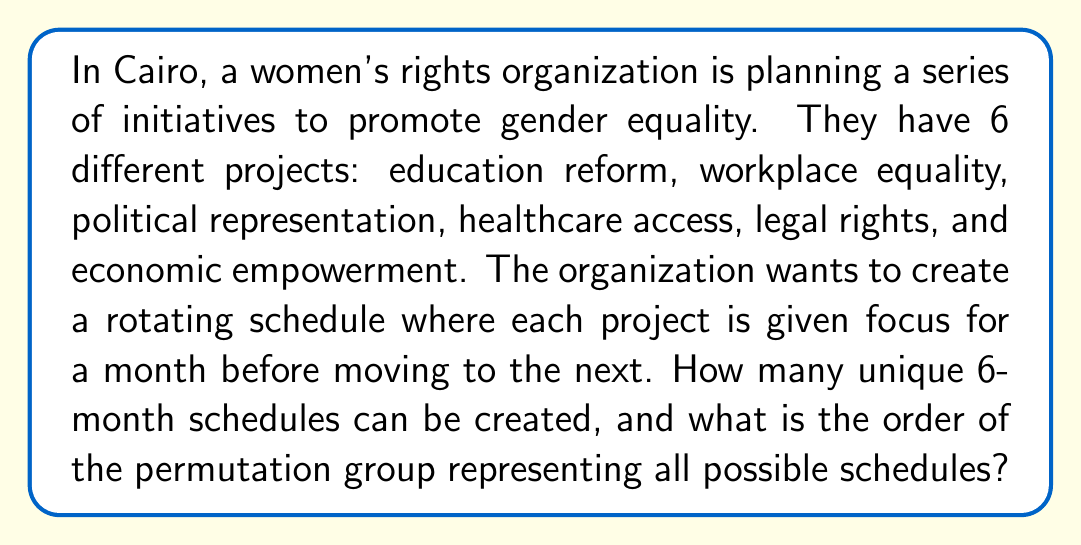What is the answer to this math problem? To solve this problem, we need to understand permutation groups and how to calculate their order.

1. First, we need to recognize that this is a permutation of 6 distinct elements (the 6 projects).

2. The number of unique permutations of n distinct elements is given by n!. In this case:

   $$\text{Number of unique schedules} = 6! = 6 \times 5 \times 4 \times 3 \times 2 \times 1 = 720$$

3. In group theory, the set of all permutations of n elements forms a group called the symmetric group $S_n$. In this case, we're dealing with $S_6$.

4. The order of a group is the number of elements in the group. For a symmetric group $S_n$, the order is always n!.

5. Therefore, the order of the permutation group representing all possible schedules is:

   $$|S_6| = 6! = 720$$

This means there are 720 elements in the group, each representing a unique 6-month schedule for the women's rights initiatives.
Answer: The number of unique 6-month schedules is 720, and the order of the permutation group representing all possible schedules is also 720. 